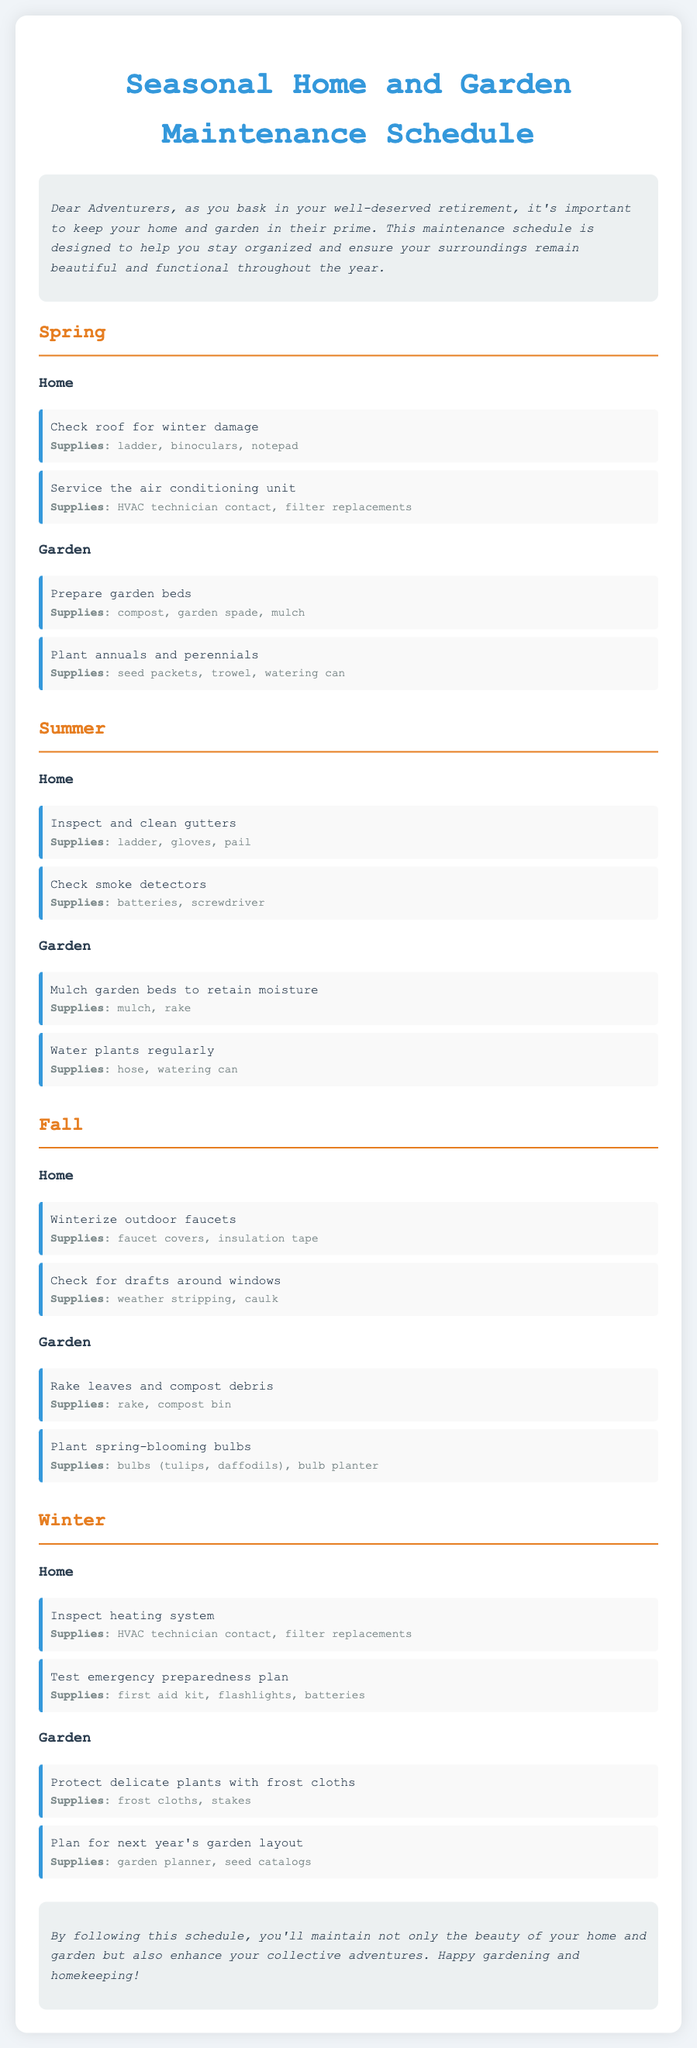What tasks should be completed in spring for the garden? The tasks for the garden in spring include preparing garden beds and planting annuals and perennials.
Answer: Prepare garden beds, Plant annuals and perennials What supplies are needed to winterize outdoor faucets? The supplies required to winterize outdoor faucets are faucet covers and insulation tape.
Answer: Faucet covers, insulation tape How many tasks are listed for the summer home maintenance? The summer home maintenance section lists two tasks: inspecting and cleaning gutters and checking smoke detectors.
Answer: 2 What supplies are needed for testing the emergency preparedness plan? The supplies needed for testing the emergency preparedness plan include a first aid kit, flashlights, and batteries.
Answer: First aid kit, flashlights, batteries Which season requires you to protect delicate plants? Winter is the season during which delicate plants should be protected with frost cloths.
Answer: Winter What is one specific task for fall home maintenance? One specific task for fall home maintenance is checking for drafts around windows.
Answer: Check for drafts around windows What do you need for mulching garden beds in summer? To mulch garden beds in summer, you need mulch and a rake.
Answer: Mulch, rake In which season do you plant spring-blooming bulbs? Spring-blooming bulbs are planted in the fall.
Answer: Fall 